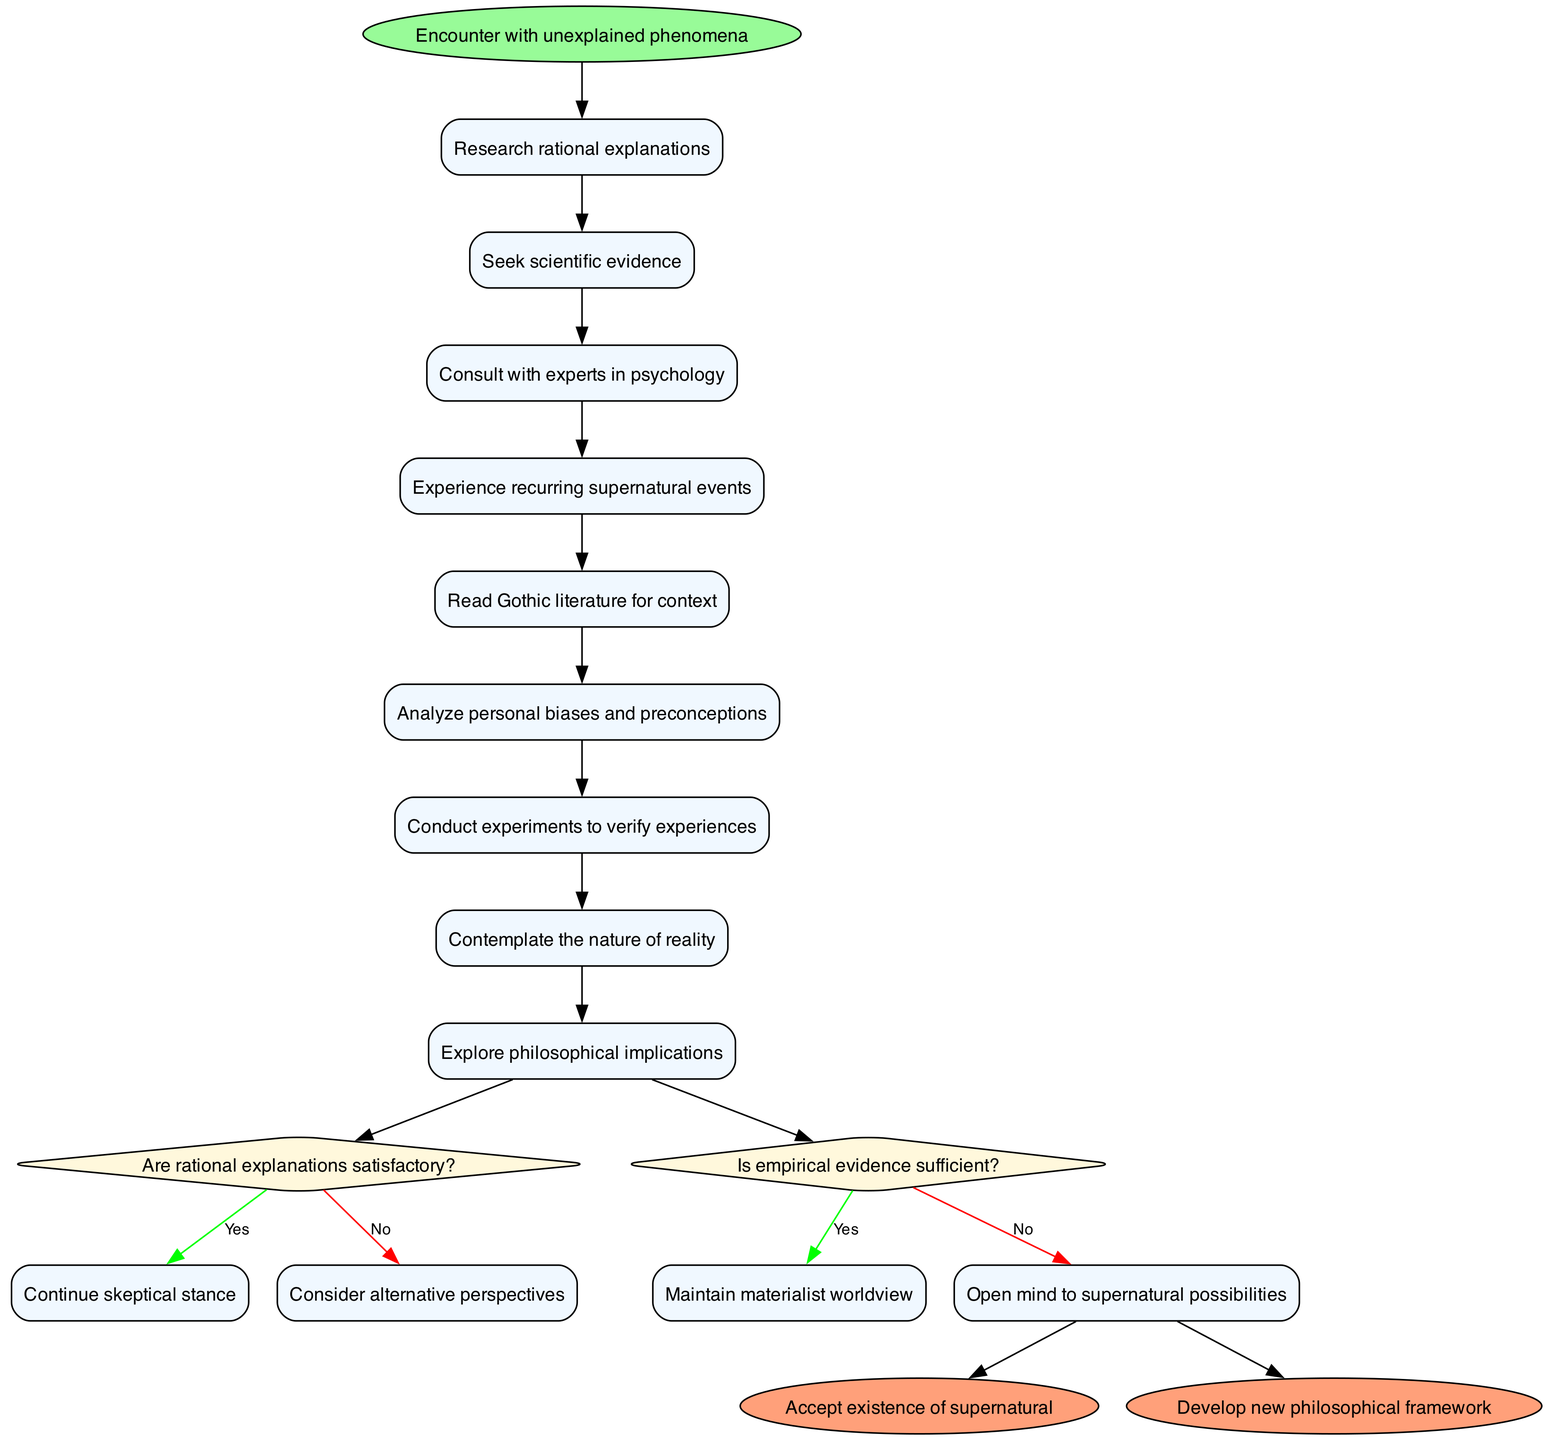What is the initial node of the diagram? The initial node is explicitly stated in the diagram as "Encounter with unexplained phenomena", which serves as the starting point for the activities.
Answer: Encounter with unexplained phenomena How many activities are listed in the diagram? To determine the number of activities, we count each item in the "activities" list in the data; there are 8 listed activities.
Answer: 8 What happens if the answer to the question "Are rational explanations satisfactory?" is yes? According to the diagram, if the answer is yes, the flow leads to "Continue skeptical stance", indicating the skeptic maintains their position.
Answer: Continue skeptical stance What do you reach after considering alternative perspectives? Following the flow from "Consider alternative perspectives," the next decision leads to the question "Is empirical evidence sufficient?" which subsequently guides further activities or outcomes.
Answer: Is empirical evidence sufficient? What is the final node that results from opening the mind to supernatural possibilities? The consequence of opening the mind to supernatural possibilities, according to the diagram, leads to one of the final nodes, "Accept existence of supernatural."
Answer: Accept existence of supernatural How are "Read Gothic literature for context" and "Analyze personal biases and preconceptions" related in the activity flow? The two activities are sequential steps within the flow of exploration after experiencing recurring supernatural events, where one activity follows after the other directly.
Answer: Sequential steps What is the last decision node in the diagram? The last decision node present in the diagram is "Is empirical evidence sufficient?", marking a critical choice point before reaching final outcomes.
Answer: Is empirical evidence sufficient? What occurs if one maintains a materialist worldview? Continuing from "Maintain materialist worldview" leads to a termination of exploration regarding the supernatural and does not pursue further philosophical implications or transformations.
Answer: Termination of exploration 